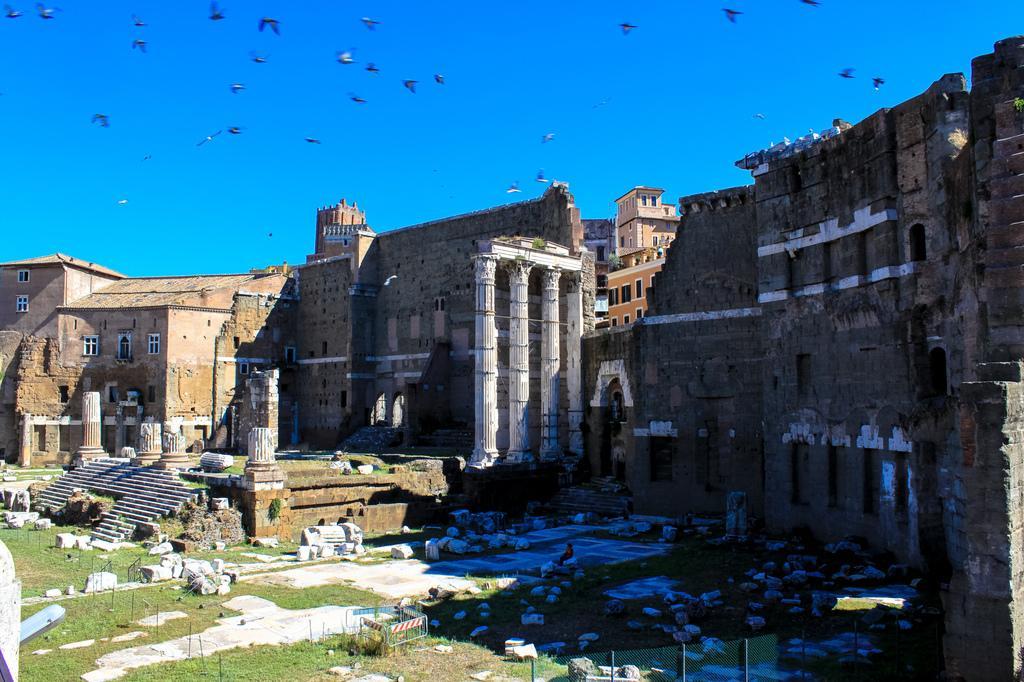Describe this image in one or two sentences. In this image there is the sky towards the top of the image, there are birds flying in the sky, there are buildings, there are pillars, there is a person standing, there is staircase, there are stones on the ground, there is grass, there is a fence towards the bottom of the image, there is a light towards the left of the image, there are windows. 